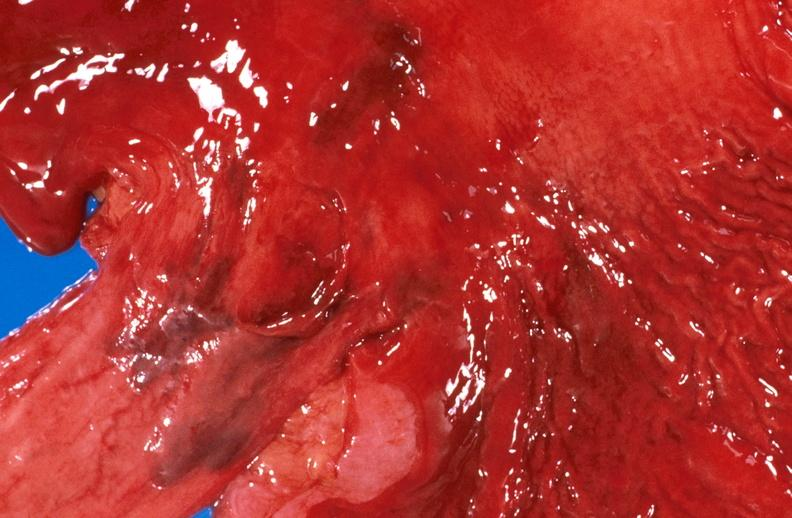what does this image show?
Answer the question using a single word or phrase. Esophageal varices due to alcoholic cirrhosis 